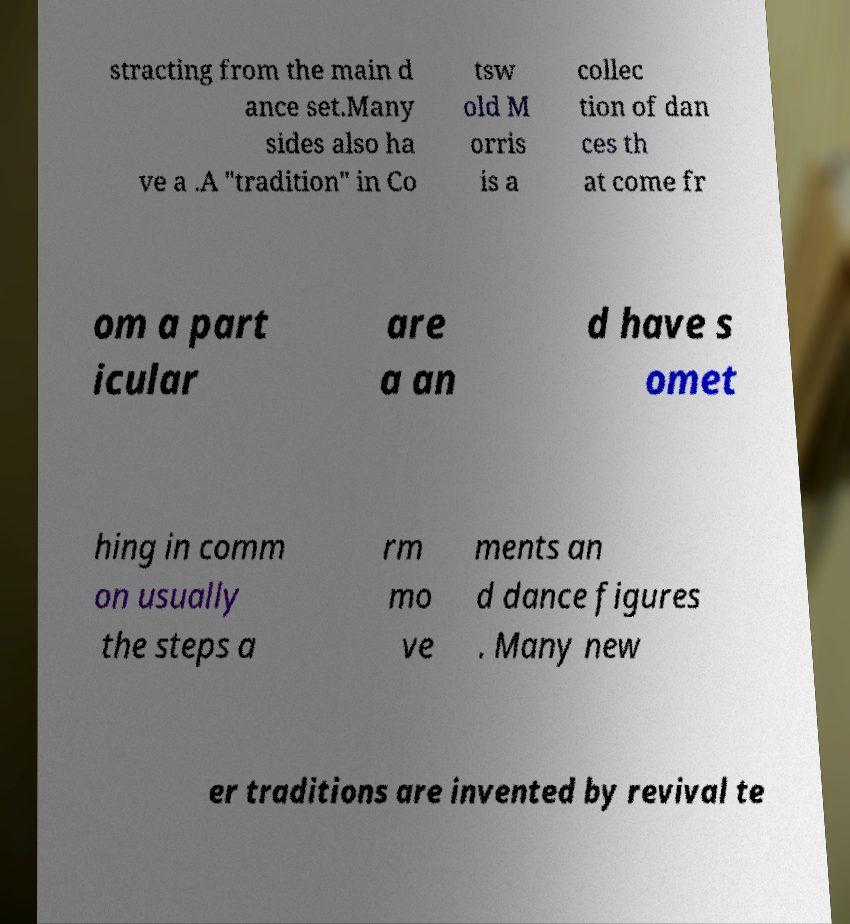Could you assist in decoding the text presented in this image and type it out clearly? stracting from the main d ance set.Many sides also ha ve a .A "tradition" in Co tsw old M orris is a collec tion of dan ces th at come fr om a part icular are a an d have s omet hing in comm on usually the steps a rm mo ve ments an d dance figures . Many new er traditions are invented by revival te 